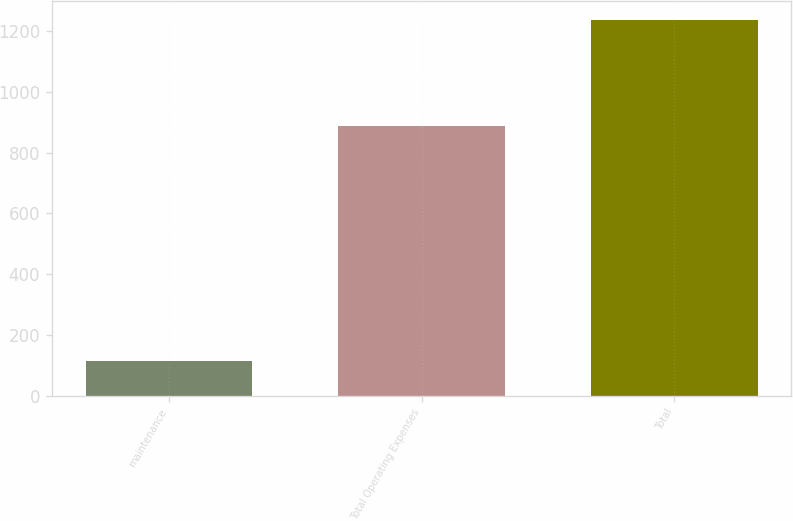Convert chart. <chart><loc_0><loc_0><loc_500><loc_500><bar_chart><fcel>maintenance<fcel>Total Operating Expenses<fcel>Total<nl><fcel>114<fcel>887<fcel>1237<nl></chart> 